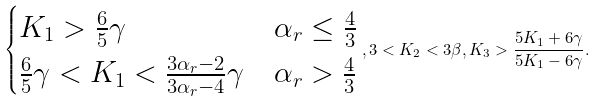<formula> <loc_0><loc_0><loc_500><loc_500>\begin{cases} K _ { 1 } > \frac { 6 } { 5 } \gamma & \alpha _ { r } \leq \frac { 4 } { 3 } \\ \frac { 6 } { 5 } \gamma < K _ { 1 } < \frac { 3 \alpha _ { r } - 2 } { 3 \alpha _ { r } - 4 } \gamma & \alpha _ { r } > \frac { 4 } { 3 } \end{cases} , 3 < K _ { 2 } < 3 \beta , K _ { 3 } > \frac { 5 K _ { 1 } + 6 \gamma } { 5 K _ { 1 } - 6 \gamma } .</formula> 